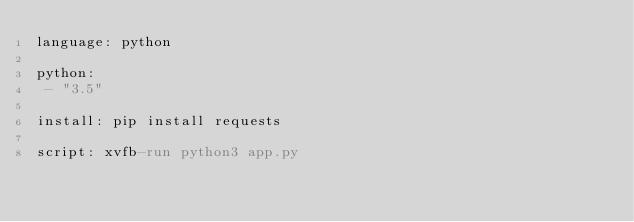<code> <loc_0><loc_0><loc_500><loc_500><_YAML_>language: python

python:
 - "3.5"

install: pip install requests

script: xvfb-run python3 app.py
</code> 